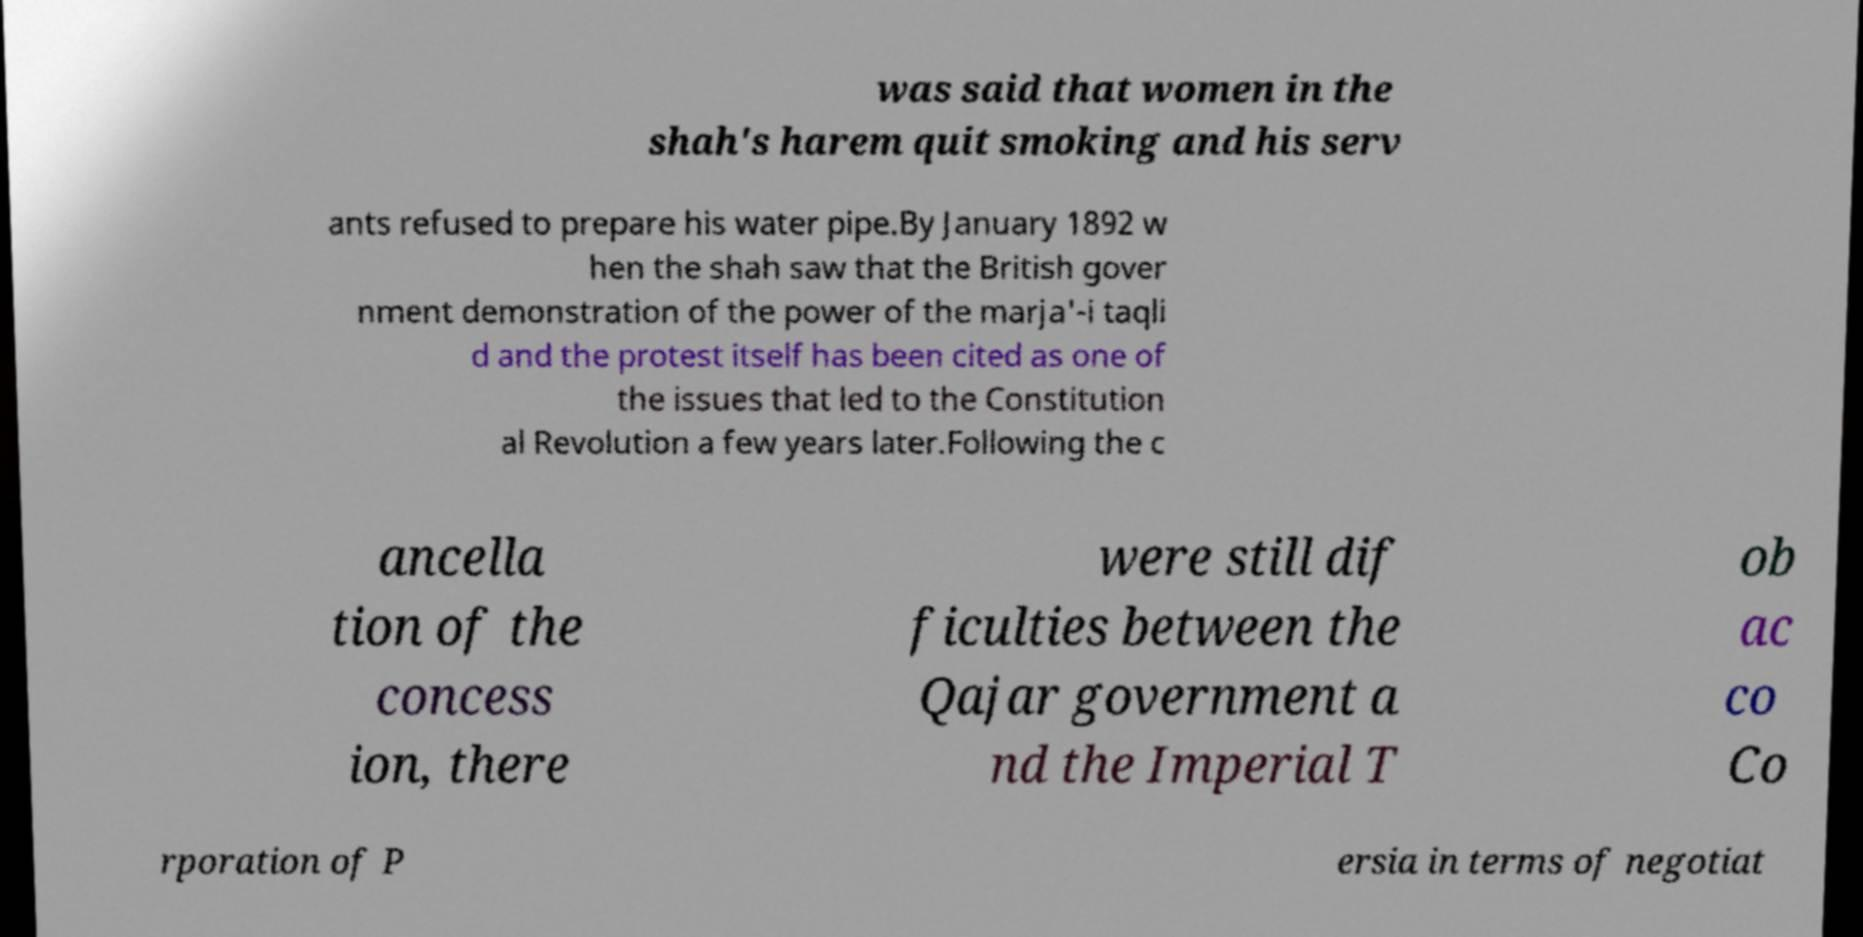There's text embedded in this image that I need extracted. Can you transcribe it verbatim? was said that women in the shah's harem quit smoking and his serv ants refused to prepare his water pipe.By January 1892 w hen the shah saw that the British gover nment demonstration of the power of the marja'-i taqli d and the protest itself has been cited as one of the issues that led to the Constitution al Revolution a few years later.Following the c ancella tion of the concess ion, there were still dif ficulties between the Qajar government a nd the Imperial T ob ac co Co rporation of P ersia in terms of negotiat 